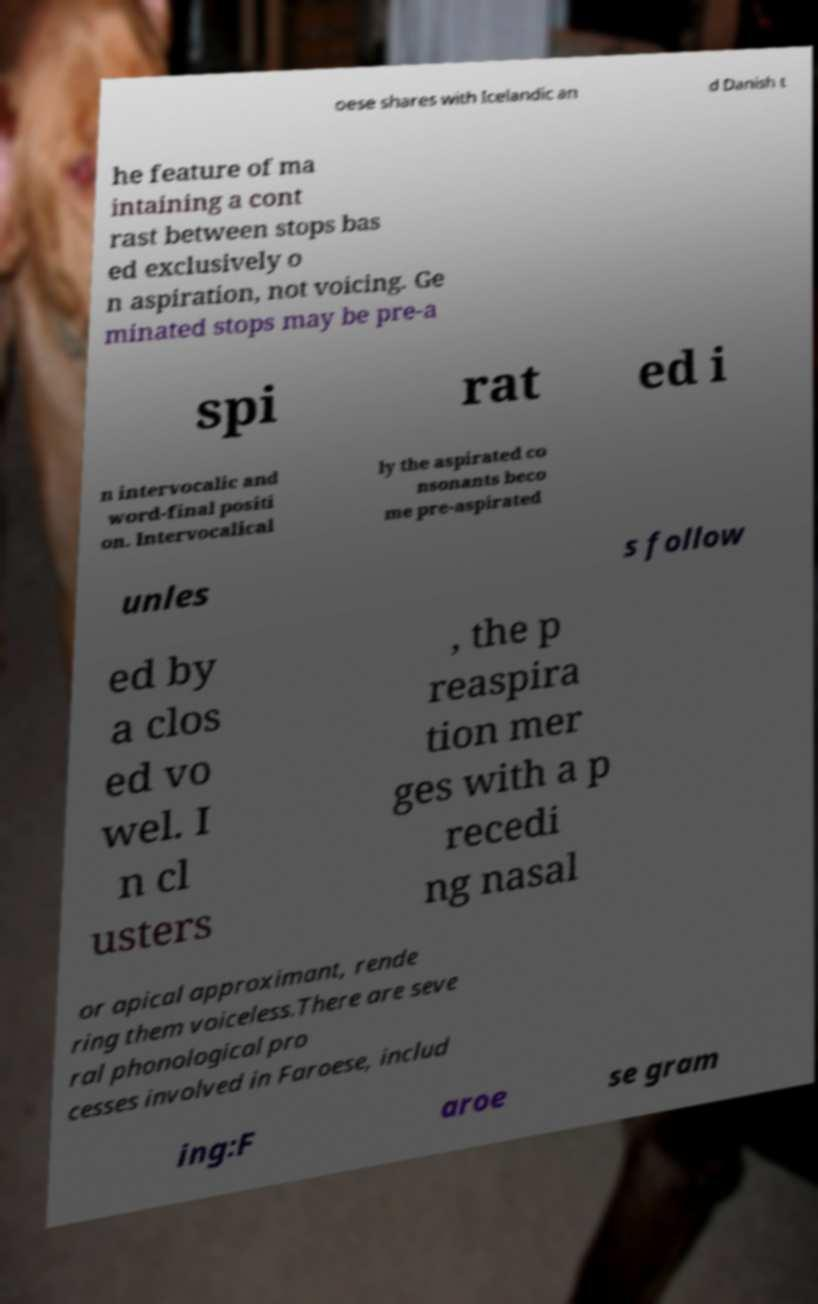Please read and relay the text visible in this image. What does it say? oese shares with Icelandic an d Danish t he feature of ma intaining a cont rast between stops bas ed exclusively o n aspiration, not voicing. Ge minated stops may be pre-a spi rat ed i n intervocalic and word-final positi on. Intervocalical ly the aspirated co nsonants beco me pre-aspirated unles s follow ed by a clos ed vo wel. I n cl usters , the p reaspira tion mer ges with a p recedi ng nasal or apical approximant, rende ring them voiceless.There are seve ral phonological pro cesses involved in Faroese, includ ing:F aroe se gram 